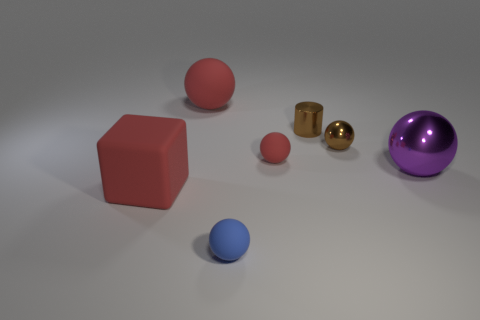Subtract 1 balls. How many balls are left? 4 Subtract all purple spheres. How many spheres are left? 4 Subtract all large shiny spheres. How many spheres are left? 4 Subtract all green balls. Subtract all green cylinders. How many balls are left? 5 Add 1 big rubber balls. How many objects exist? 8 Subtract all cubes. How many objects are left? 6 Add 1 small red rubber objects. How many small red rubber objects are left? 2 Add 5 big purple metallic spheres. How many big purple metallic spheres exist? 6 Subtract 0 red cylinders. How many objects are left? 7 Subtract all big rubber balls. Subtract all big purple balls. How many objects are left? 5 